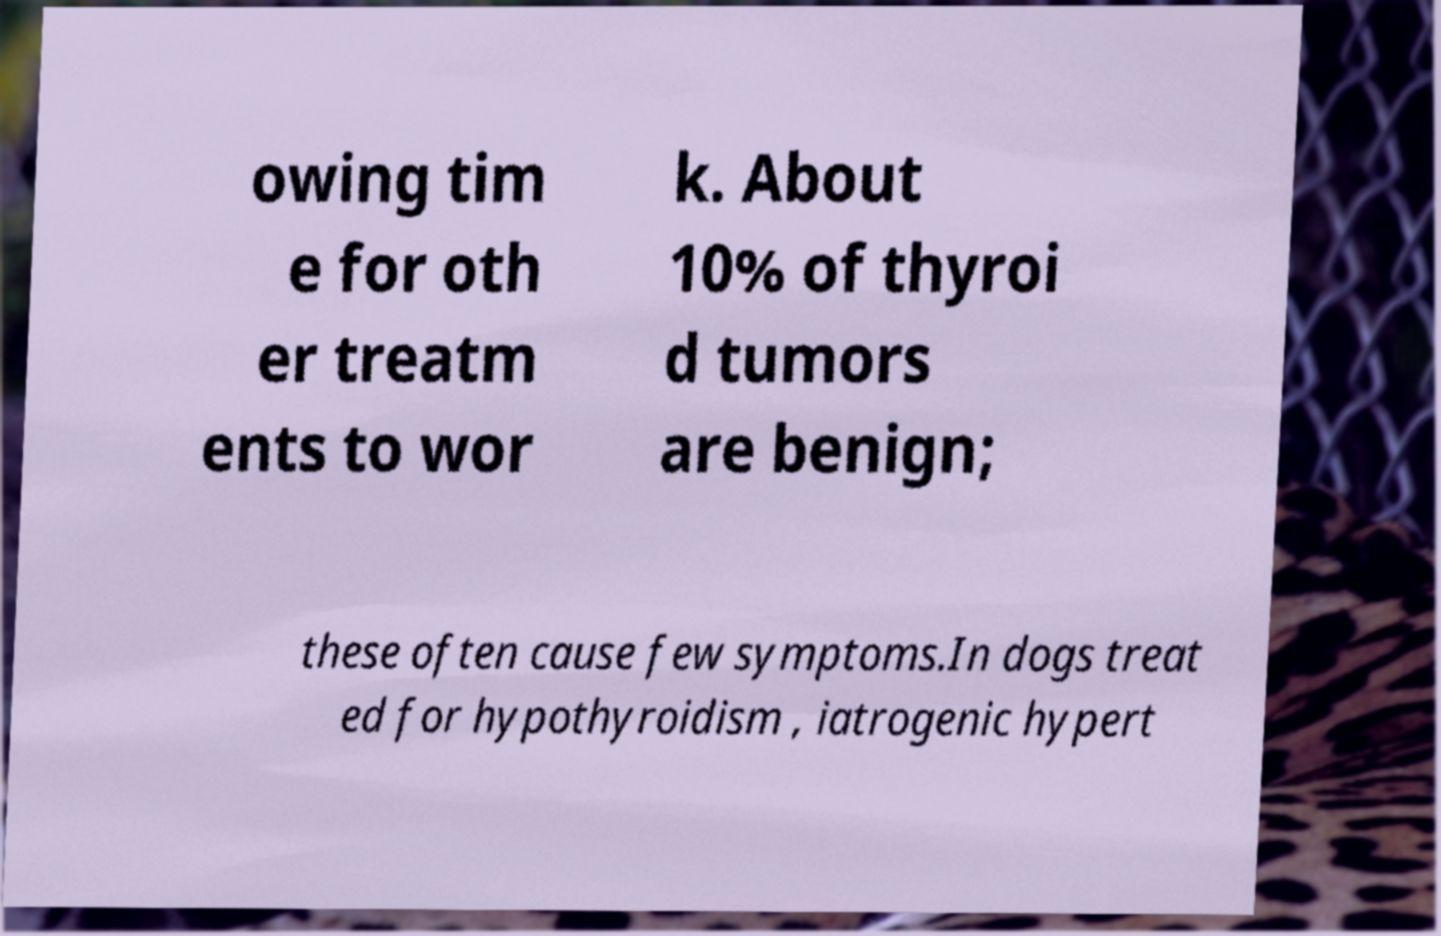For documentation purposes, I need the text within this image transcribed. Could you provide that? owing tim e for oth er treatm ents to wor k. About 10% of thyroi d tumors are benign; these often cause few symptoms.In dogs treat ed for hypothyroidism , iatrogenic hypert 